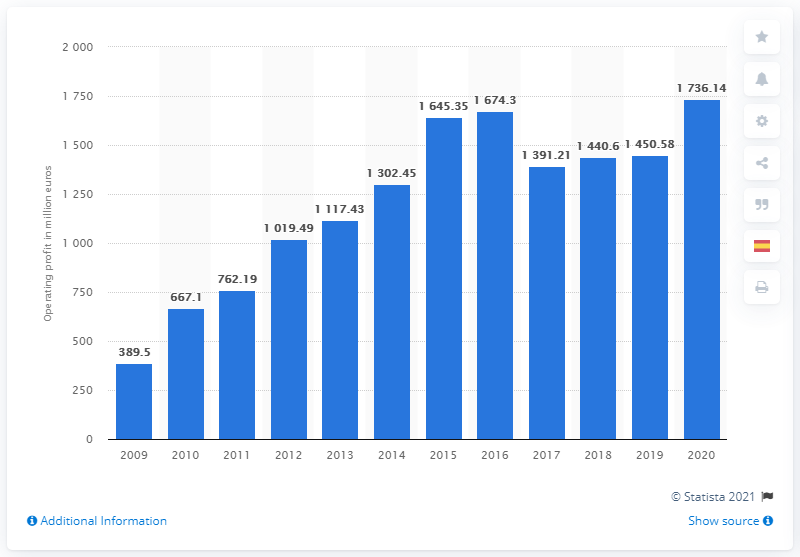List a handful of essential elements in this visual. In 2020, the LEGO Group's operating profit was 1736.14. 